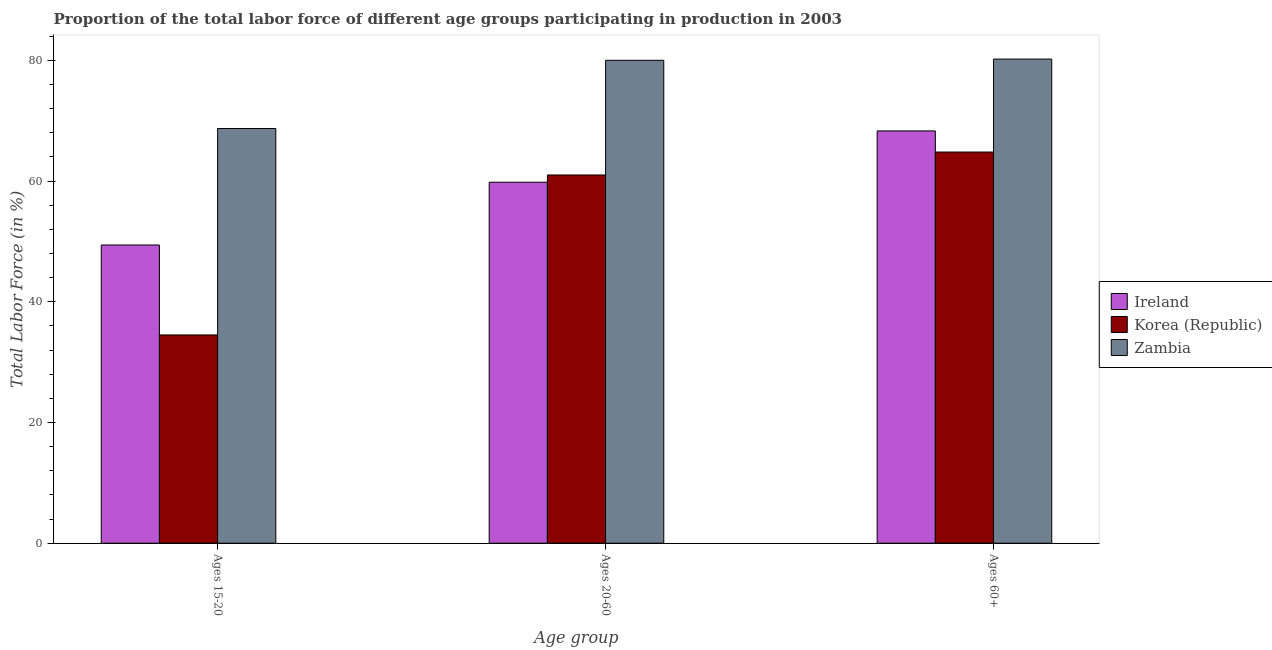How many different coloured bars are there?
Offer a very short reply. 3. How many groups of bars are there?
Make the answer very short. 3. Are the number of bars per tick equal to the number of legend labels?
Your response must be concise. Yes. Are the number of bars on each tick of the X-axis equal?
Give a very brief answer. Yes. How many bars are there on the 3rd tick from the left?
Your answer should be very brief. 3. What is the label of the 2nd group of bars from the left?
Your answer should be very brief. Ages 20-60. What is the percentage of labor force above age 60 in Ireland?
Ensure brevity in your answer.  68.3. Across all countries, what is the maximum percentage of labor force above age 60?
Give a very brief answer. 80.2. Across all countries, what is the minimum percentage of labor force within the age group 15-20?
Provide a short and direct response. 34.5. In which country was the percentage of labor force above age 60 maximum?
Your answer should be very brief. Zambia. In which country was the percentage of labor force within the age group 15-20 minimum?
Provide a succinct answer. Korea (Republic). What is the total percentage of labor force within the age group 15-20 in the graph?
Your answer should be very brief. 152.6. What is the difference between the percentage of labor force within the age group 20-60 in Zambia and that in Ireland?
Make the answer very short. 20.2. What is the difference between the percentage of labor force within the age group 15-20 in Zambia and the percentage of labor force above age 60 in Ireland?
Give a very brief answer. 0.4. What is the average percentage of labor force within the age group 20-60 per country?
Ensure brevity in your answer.  66.93. What is the difference between the percentage of labor force within the age group 20-60 and percentage of labor force above age 60 in Ireland?
Make the answer very short. -8.5. What is the ratio of the percentage of labor force within the age group 15-20 in Korea (Republic) to that in Ireland?
Ensure brevity in your answer.  0.7. What is the difference between the highest and the second highest percentage of labor force within the age group 15-20?
Make the answer very short. 19.3. What is the difference between the highest and the lowest percentage of labor force above age 60?
Provide a short and direct response. 15.4. What does the 2nd bar from the left in Ages 60+ represents?
Provide a short and direct response. Korea (Republic). What does the 2nd bar from the right in Ages 60+ represents?
Make the answer very short. Korea (Republic). Is it the case that in every country, the sum of the percentage of labor force within the age group 15-20 and percentage of labor force within the age group 20-60 is greater than the percentage of labor force above age 60?
Offer a terse response. Yes. Are all the bars in the graph horizontal?
Your answer should be compact. No. What is the difference between two consecutive major ticks on the Y-axis?
Keep it short and to the point. 20. Are the values on the major ticks of Y-axis written in scientific E-notation?
Your answer should be very brief. No. Does the graph contain any zero values?
Offer a terse response. No. Where does the legend appear in the graph?
Your answer should be very brief. Center right. How many legend labels are there?
Offer a terse response. 3. How are the legend labels stacked?
Your answer should be very brief. Vertical. What is the title of the graph?
Provide a short and direct response. Proportion of the total labor force of different age groups participating in production in 2003. What is the label or title of the X-axis?
Make the answer very short. Age group. What is the Total Labor Force (in %) in Ireland in Ages 15-20?
Provide a succinct answer. 49.4. What is the Total Labor Force (in %) of Korea (Republic) in Ages 15-20?
Your response must be concise. 34.5. What is the Total Labor Force (in %) of Zambia in Ages 15-20?
Provide a short and direct response. 68.7. What is the Total Labor Force (in %) in Ireland in Ages 20-60?
Provide a succinct answer. 59.8. What is the Total Labor Force (in %) in Korea (Republic) in Ages 20-60?
Your response must be concise. 61. What is the Total Labor Force (in %) in Ireland in Ages 60+?
Offer a very short reply. 68.3. What is the Total Labor Force (in %) of Korea (Republic) in Ages 60+?
Your response must be concise. 64.8. What is the Total Labor Force (in %) in Zambia in Ages 60+?
Make the answer very short. 80.2. Across all Age group, what is the maximum Total Labor Force (in %) in Ireland?
Your response must be concise. 68.3. Across all Age group, what is the maximum Total Labor Force (in %) of Korea (Republic)?
Your answer should be very brief. 64.8. Across all Age group, what is the maximum Total Labor Force (in %) in Zambia?
Your answer should be very brief. 80.2. Across all Age group, what is the minimum Total Labor Force (in %) of Ireland?
Make the answer very short. 49.4. Across all Age group, what is the minimum Total Labor Force (in %) in Korea (Republic)?
Your answer should be compact. 34.5. Across all Age group, what is the minimum Total Labor Force (in %) of Zambia?
Your response must be concise. 68.7. What is the total Total Labor Force (in %) of Ireland in the graph?
Your answer should be very brief. 177.5. What is the total Total Labor Force (in %) of Korea (Republic) in the graph?
Keep it short and to the point. 160.3. What is the total Total Labor Force (in %) of Zambia in the graph?
Keep it short and to the point. 228.9. What is the difference between the Total Labor Force (in %) in Ireland in Ages 15-20 and that in Ages 20-60?
Your answer should be compact. -10.4. What is the difference between the Total Labor Force (in %) in Korea (Republic) in Ages 15-20 and that in Ages 20-60?
Offer a terse response. -26.5. What is the difference between the Total Labor Force (in %) in Zambia in Ages 15-20 and that in Ages 20-60?
Your response must be concise. -11.3. What is the difference between the Total Labor Force (in %) of Ireland in Ages 15-20 and that in Ages 60+?
Offer a very short reply. -18.9. What is the difference between the Total Labor Force (in %) of Korea (Republic) in Ages 15-20 and that in Ages 60+?
Your answer should be compact. -30.3. What is the difference between the Total Labor Force (in %) of Zambia in Ages 15-20 and that in Ages 60+?
Your response must be concise. -11.5. What is the difference between the Total Labor Force (in %) in Korea (Republic) in Ages 20-60 and that in Ages 60+?
Offer a terse response. -3.8. What is the difference between the Total Labor Force (in %) in Ireland in Ages 15-20 and the Total Labor Force (in %) in Zambia in Ages 20-60?
Your answer should be very brief. -30.6. What is the difference between the Total Labor Force (in %) of Korea (Republic) in Ages 15-20 and the Total Labor Force (in %) of Zambia in Ages 20-60?
Your response must be concise. -45.5. What is the difference between the Total Labor Force (in %) in Ireland in Ages 15-20 and the Total Labor Force (in %) in Korea (Republic) in Ages 60+?
Offer a terse response. -15.4. What is the difference between the Total Labor Force (in %) of Ireland in Ages 15-20 and the Total Labor Force (in %) of Zambia in Ages 60+?
Make the answer very short. -30.8. What is the difference between the Total Labor Force (in %) of Korea (Republic) in Ages 15-20 and the Total Labor Force (in %) of Zambia in Ages 60+?
Ensure brevity in your answer.  -45.7. What is the difference between the Total Labor Force (in %) of Ireland in Ages 20-60 and the Total Labor Force (in %) of Korea (Republic) in Ages 60+?
Offer a terse response. -5. What is the difference between the Total Labor Force (in %) in Ireland in Ages 20-60 and the Total Labor Force (in %) in Zambia in Ages 60+?
Your answer should be compact. -20.4. What is the difference between the Total Labor Force (in %) of Korea (Republic) in Ages 20-60 and the Total Labor Force (in %) of Zambia in Ages 60+?
Ensure brevity in your answer.  -19.2. What is the average Total Labor Force (in %) of Ireland per Age group?
Your answer should be very brief. 59.17. What is the average Total Labor Force (in %) in Korea (Republic) per Age group?
Provide a succinct answer. 53.43. What is the average Total Labor Force (in %) in Zambia per Age group?
Offer a terse response. 76.3. What is the difference between the Total Labor Force (in %) of Ireland and Total Labor Force (in %) of Zambia in Ages 15-20?
Your answer should be very brief. -19.3. What is the difference between the Total Labor Force (in %) in Korea (Republic) and Total Labor Force (in %) in Zambia in Ages 15-20?
Your response must be concise. -34.2. What is the difference between the Total Labor Force (in %) of Ireland and Total Labor Force (in %) of Korea (Republic) in Ages 20-60?
Provide a short and direct response. -1.2. What is the difference between the Total Labor Force (in %) in Ireland and Total Labor Force (in %) in Zambia in Ages 20-60?
Keep it short and to the point. -20.2. What is the difference between the Total Labor Force (in %) in Korea (Republic) and Total Labor Force (in %) in Zambia in Ages 20-60?
Your answer should be compact. -19. What is the difference between the Total Labor Force (in %) in Ireland and Total Labor Force (in %) in Zambia in Ages 60+?
Provide a succinct answer. -11.9. What is the difference between the Total Labor Force (in %) in Korea (Republic) and Total Labor Force (in %) in Zambia in Ages 60+?
Keep it short and to the point. -15.4. What is the ratio of the Total Labor Force (in %) of Ireland in Ages 15-20 to that in Ages 20-60?
Keep it short and to the point. 0.83. What is the ratio of the Total Labor Force (in %) in Korea (Republic) in Ages 15-20 to that in Ages 20-60?
Give a very brief answer. 0.57. What is the ratio of the Total Labor Force (in %) in Zambia in Ages 15-20 to that in Ages 20-60?
Keep it short and to the point. 0.86. What is the ratio of the Total Labor Force (in %) in Ireland in Ages 15-20 to that in Ages 60+?
Offer a terse response. 0.72. What is the ratio of the Total Labor Force (in %) of Korea (Republic) in Ages 15-20 to that in Ages 60+?
Offer a terse response. 0.53. What is the ratio of the Total Labor Force (in %) of Zambia in Ages 15-20 to that in Ages 60+?
Your answer should be very brief. 0.86. What is the ratio of the Total Labor Force (in %) of Ireland in Ages 20-60 to that in Ages 60+?
Provide a succinct answer. 0.88. What is the ratio of the Total Labor Force (in %) of Korea (Republic) in Ages 20-60 to that in Ages 60+?
Offer a terse response. 0.94. What is the ratio of the Total Labor Force (in %) of Zambia in Ages 20-60 to that in Ages 60+?
Provide a short and direct response. 1. What is the difference between the highest and the second highest Total Labor Force (in %) of Korea (Republic)?
Offer a terse response. 3.8. What is the difference between the highest and the lowest Total Labor Force (in %) of Ireland?
Keep it short and to the point. 18.9. What is the difference between the highest and the lowest Total Labor Force (in %) in Korea (Republic)?
Ensure brevity in your answer.  30.3. What is the difference between the highest and the lowest Total Labor Force (in %) of Zambia?
Offer a very short reply. 11.5. 